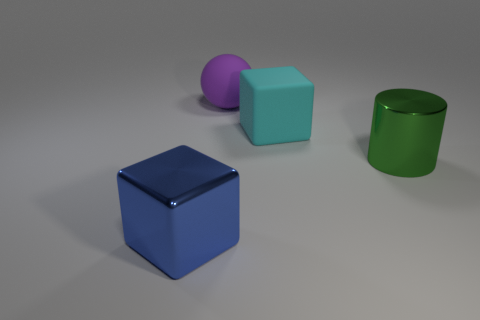Add 1 big purple spheres. How many objects exist? 5 Subtract all cyan cubes. How many cubes are left? 1 Subtract all cylinders. How many objects are left? 3 Add 4 large purple rubber spheres. How many large purple rubber spheres are left? 5 Add 3 large red metallic balls. How many large red metallic balls exist? 3 Subtract 1 purple spheres. How many objects are left? 3 Subtract 1 blocks. How many blocks are left? 1 Subtract all green blocks. Subtract all cyan spheres. How many blocks are left? 2 Subtract all metallic objects. Subtract all matte objects. How many objects are left? 0 